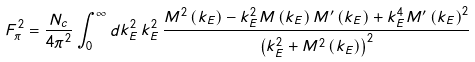Convert formula to latex. <formula><loc_0><loc_0><loc_500><loc_500>F _ { \pi } ^ { 2 } = \frac { N _ { c } } { 4 \pi ^ { 2 } } \int _ { 0 } ^ { \infty } d k _ { E } ^ { 2 } \, k _ { E } ^ { 2 } \, \frac { M ^ { 2 } \left ( k _ { E } \right ) - k _ { E } ^ { 2 } M \left ( k _ { E } \right ) M ^ { \prime } \left ( k _ { E } \right ) + k _ { E } ^ { 4 } M ^ { \prime } \left ( k _ { E } \right ) ^ { 2 } } { \left ( k _ { E } ^ { 2 } + M ^ { 2 } \left ( k _ { E } \right ) \right ) ^ { 2 } }</formula> 